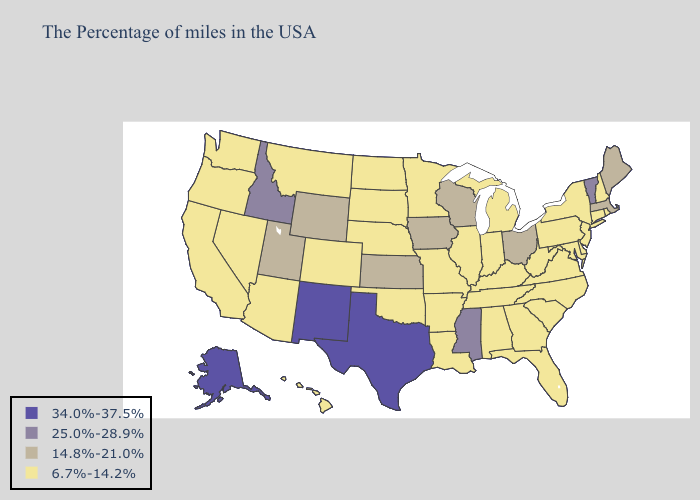Name the states that have a value in the range 34.0%-37.5%?
Be succinct. Texas, New Mexico, Alaska. What is the lowest value in the Northeast?
Short answer required. 6.7%-14.2%. What is the lowest value in states that border Mississippi?
Give a very brief answer. 6.7%-14.2%. Does Hawaii have a lower value than Texas?
Quick response, please. Yes. What is the highest value in the USA?
Write a very short answer. 34.0%-37.5%. Name the states that have a value in the range 34.0%-37.5%?
Give a very brief answer. Texas, New Mexico, Alaska. Which states have the highest value in the USA?
Short answer required. Texas, New Mexico, Alaska. Does New Jersey have the lowest value in the Northeast?
Short answer required. Yes. What is the value of Louisiana?
Short answer required. 6.7%-14.2%. What is the value of Kentucky?
Concise answer only. 6.7%-14.2%. What is the highest value in states that border Idaho?
Concise answer only. 14.8%-21.0%. What is the value of Oklahoma?
Keep it brief. 6.7%-14.2%. Among the states that border Indiana , does Ohio have the highest value?
Be succinct. Yes. What is the highest value in states that border South Dakota?
Concise answer only. 14.8%-21.0%. 